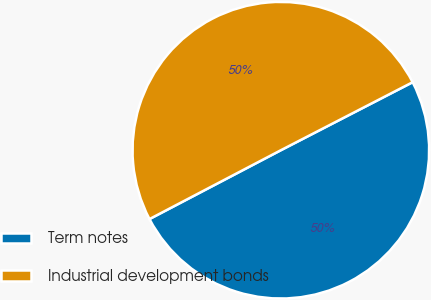Convert chart to OTSL. <chart><loc_0><loc_0><loc_500><loc_500><pie_chart><fcel>Term notes<fcel>Industrial development bonds<nl><fcel>49.9%<fcel>50.1%<nl></chart> 